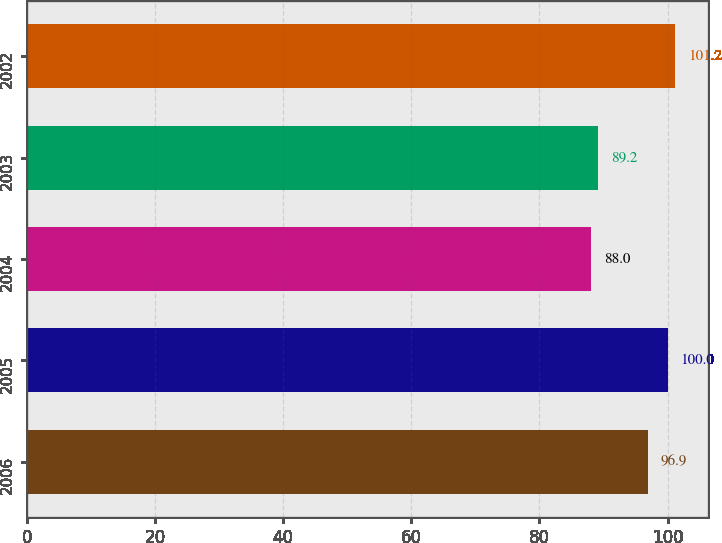<chart> <loc_0><loc_0><loc_500><loc_500><bar_chart><fcel>2006<fcel>2005<fcel>2004<fcel>2003<fcel>2002<nl><fcel>96.9<fcel>100<fcel>88<fcel>89.2<fcel>101.2<nl></chart> 